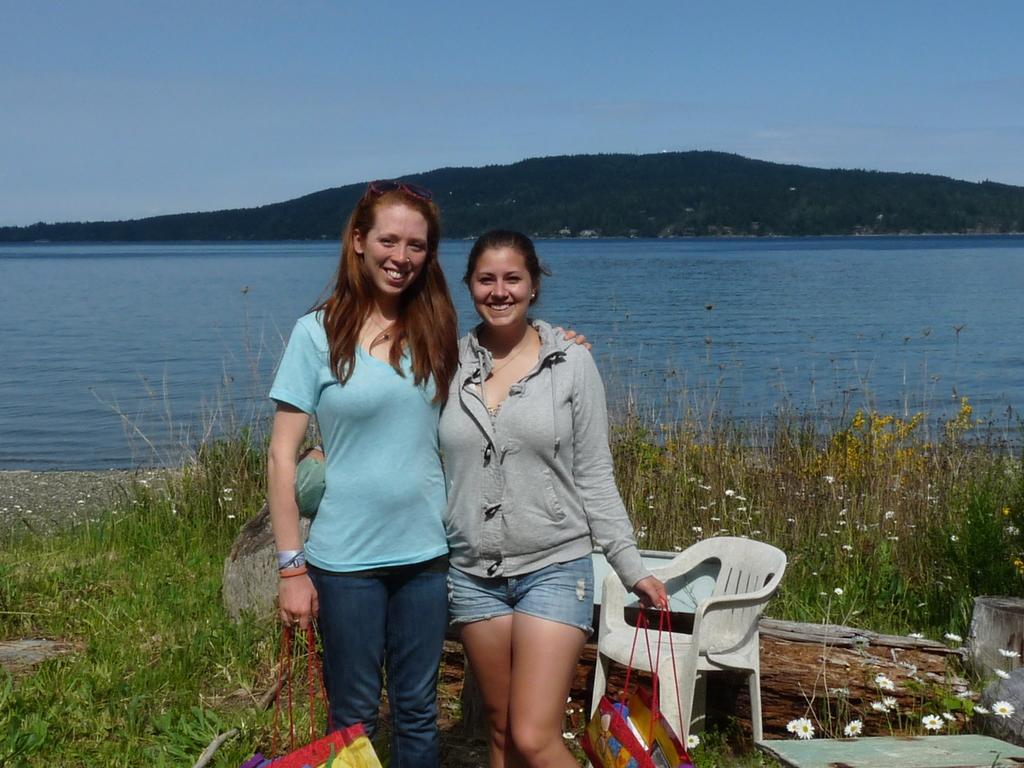In one or two sentences, can you explain what this image depicts? In the image we can see there are women who are standing and they are holding bags and at the back there is river. 